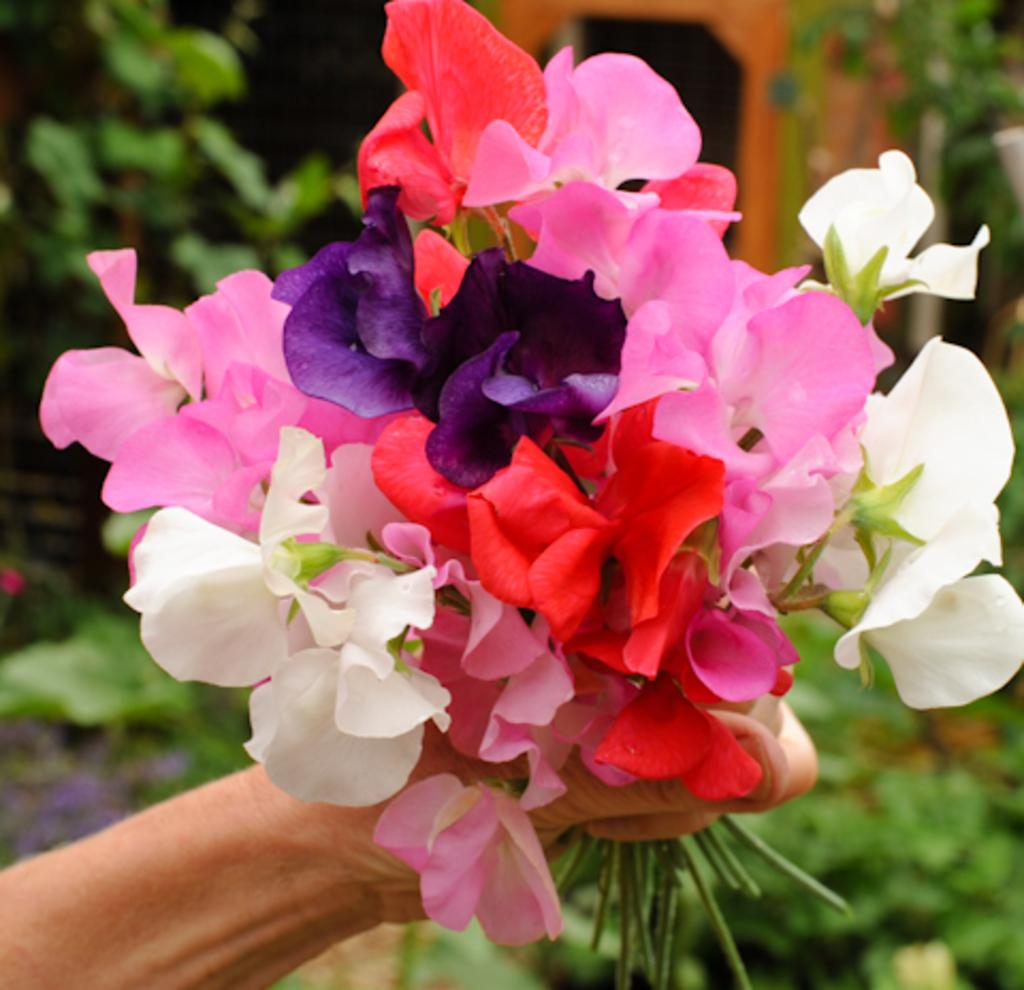What is the person in the image holding? The person is holding colorful flowers in the image. What can be seen in the background of the image? There are plants in the background of the image. Can you describe the brown object in the background? The brown object in the background is blurry, so it is difficult to describe its exact nature. What is the person's opinion about the bell in the image? There is no bell present in the image, so it is not possible to determine the person's opinion about it. 